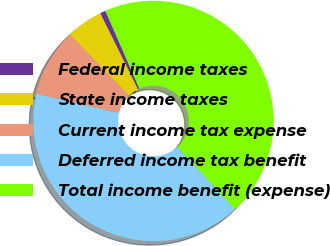Convert chart to OTSL. <chart><loc_0><loc_0><loc_500><loc_500><pie_chart><fcel>Federal income taxes<fcel>State income taxes<fcel>Current income tax expense<fcel>Deferred income tax benefit<fcel>Total income benefit (expense)<nl><fcel>0.74%<fcel>4.94%<fcel>9.14%<fcel>40.49%<fcel>44.69%<nl></chart> 